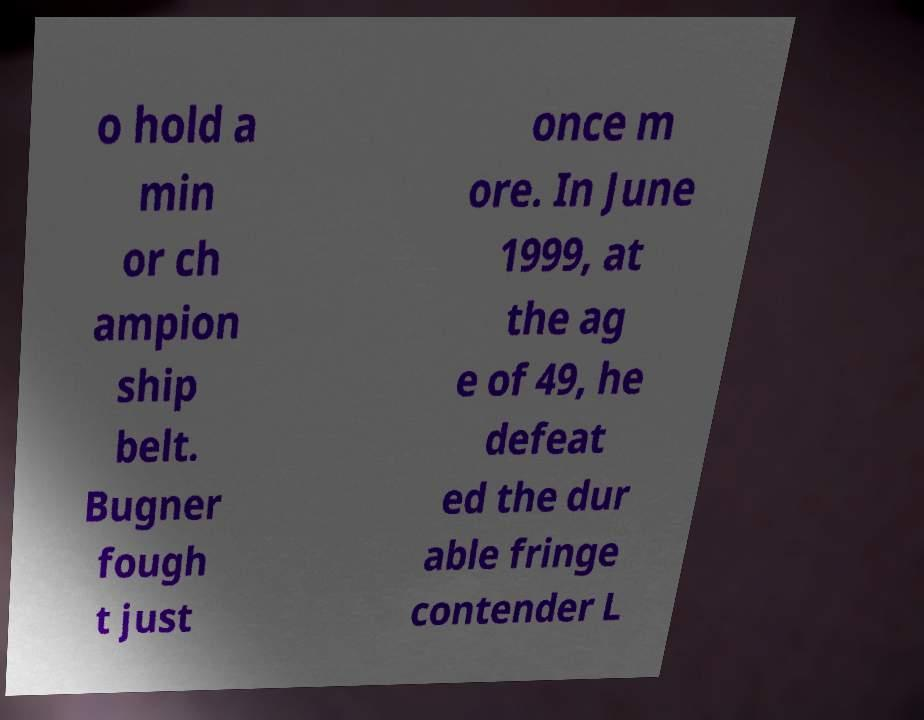There's text embedded in this image that I need extracted. Can you transcribe it verbatim? o hold a min or ch ampion ship belt. Bugner fough t just once m ore. In June 1999, at the ag e of 49, he defeat ed the dur able fringe contender L 